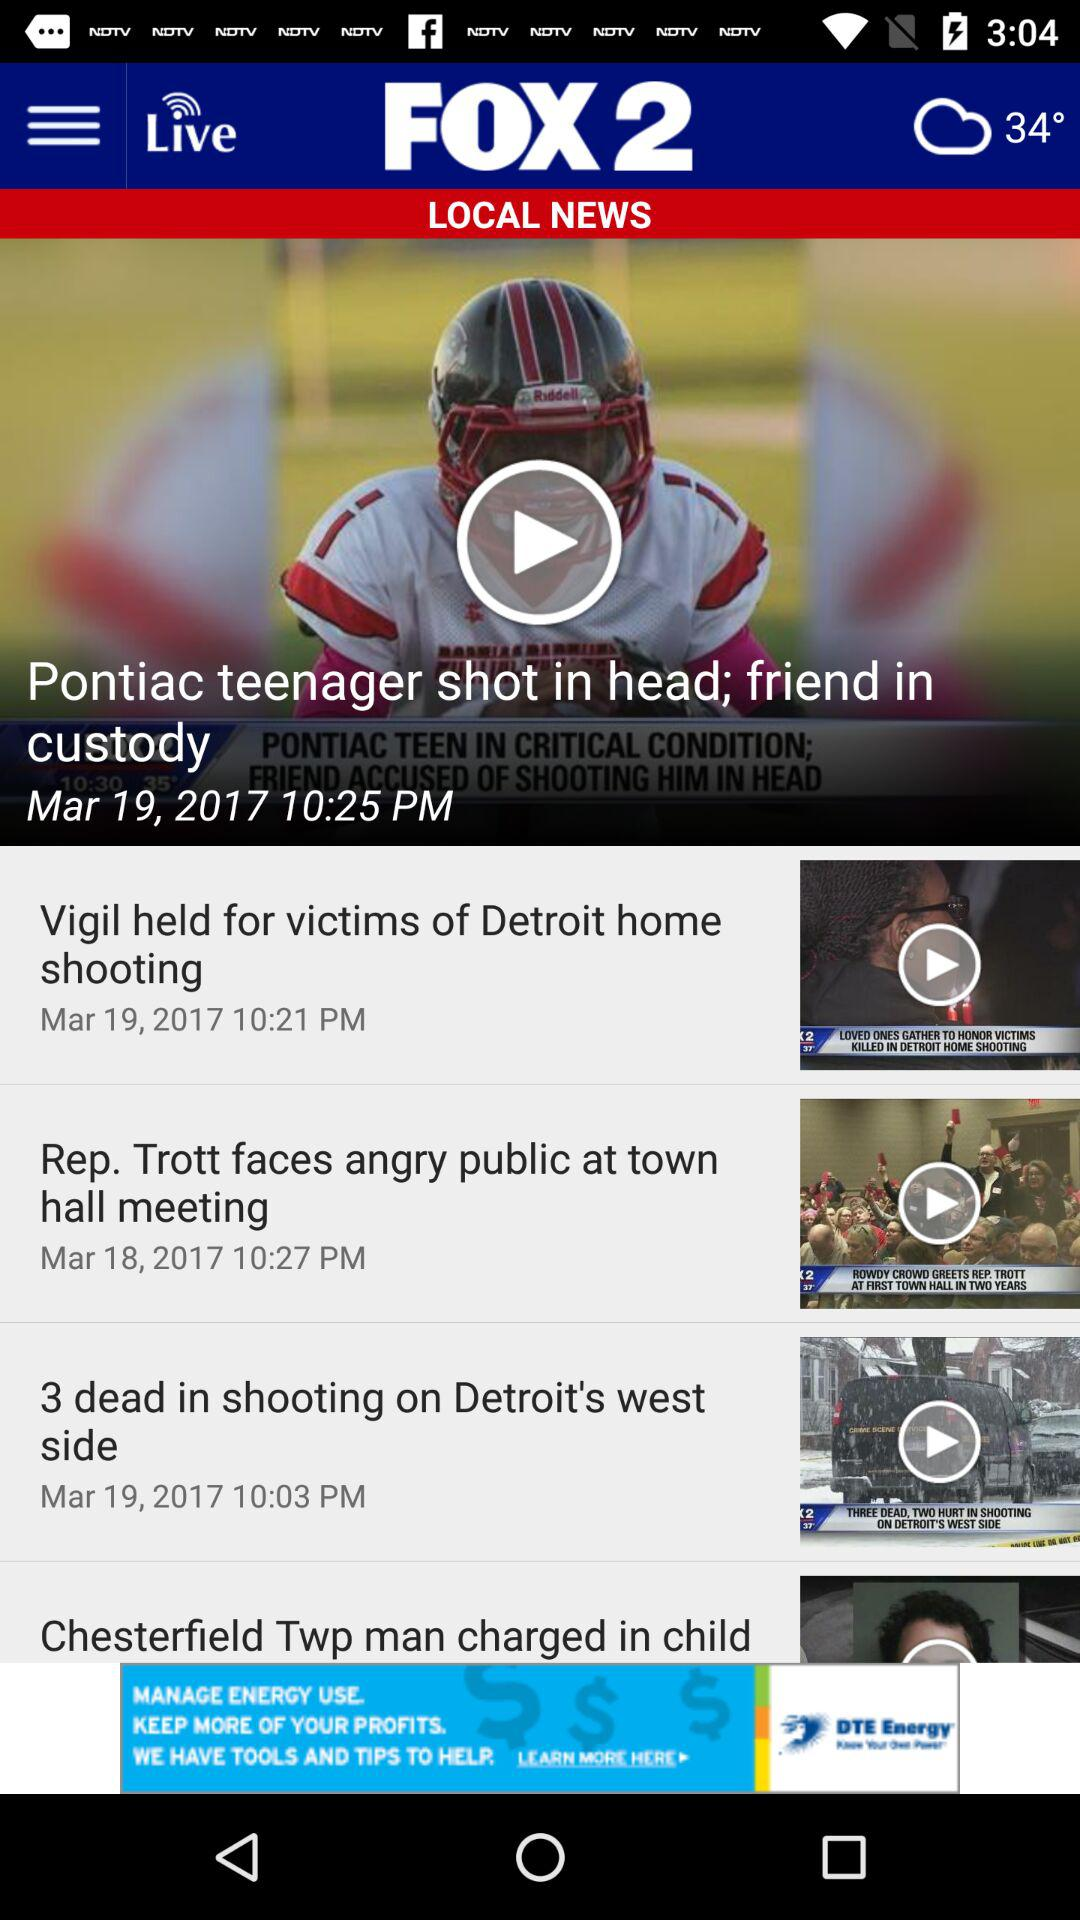What is the headline of the news? The headline of the news is "Pontiac teenager shot in head; friend in custody ". 